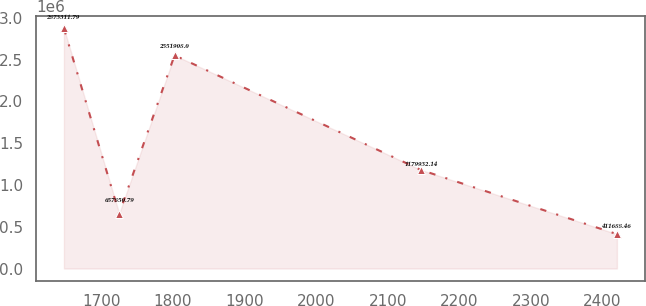Convert chart to OTSL. <chart><loc_0><loc_0><loc_500><loc_500><line_chart><ecel><fcel>Unnamed: 1<nl><fcel>1648.02<fcel>2.87331e+06<nl><fcel>1725.22<fcel>657851<nl><fcel>1802.42<fcel>2.55191e+06<nl><fcel>2146.27<fcel>1.17993e+06<nl><fcel>2420.06<fcel>411688<nl></chart> 